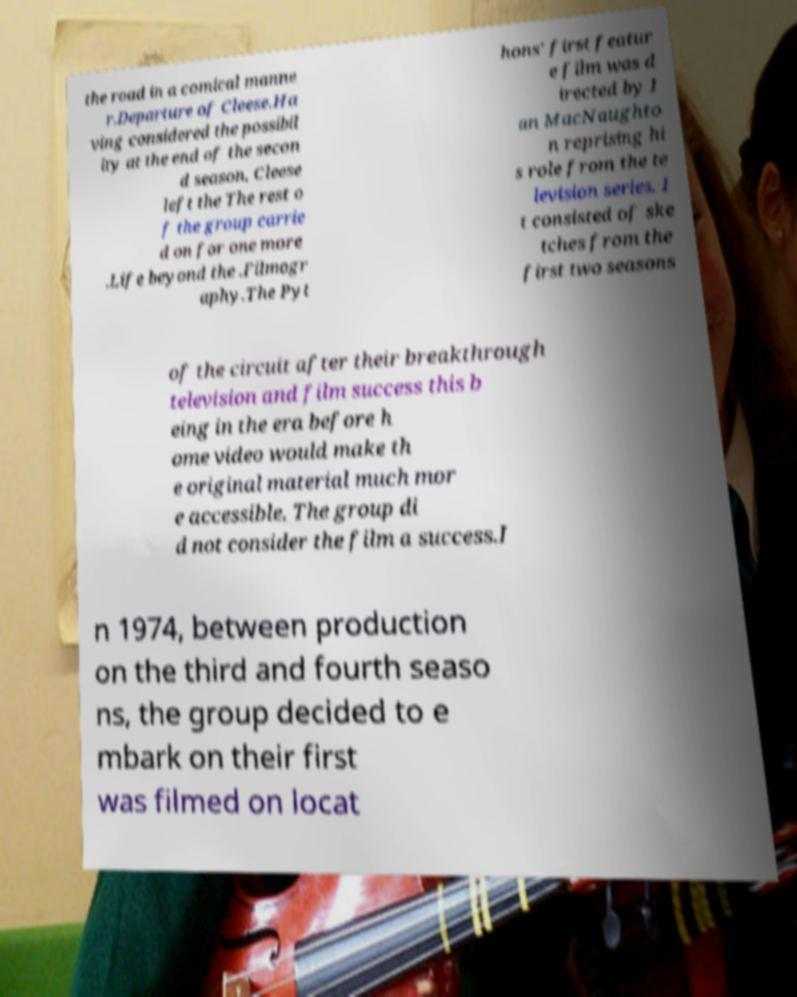There's text embedded in this image that I need extracted. Can you transcribe it verbatim? the road in a comical manne r.Departure of Cleese.Ha ving considered the possibil ity at the end of the secon d season, Cleese left the The rest o f the group carrie d on for one more .Life beyond the .Filmogr aphy.The Pyt hons' first featur e film was d irected by I an MacNaughto n reprising hi s role from the te levision series. I t consisted of ske tches from the first two seasons of the circuit after their breakthrough television and film success this b eing in the era before h ome video would make th e original material much mor e accessible. The group di d not consider the film a success.I n 1974, between production on the third and fourth seaso ns, the group decided to e mbark on their first was filmed on locat 